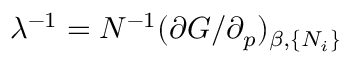Convert formula to latex. <formula><loc_0><loc_0><loc_500><loc_500>\lambda ^ { - 1 } = N ^ { - 1 } ( \partial G / \partial _ { p } ) _ { \beta , \{ N _ { i } \} }</formula> 